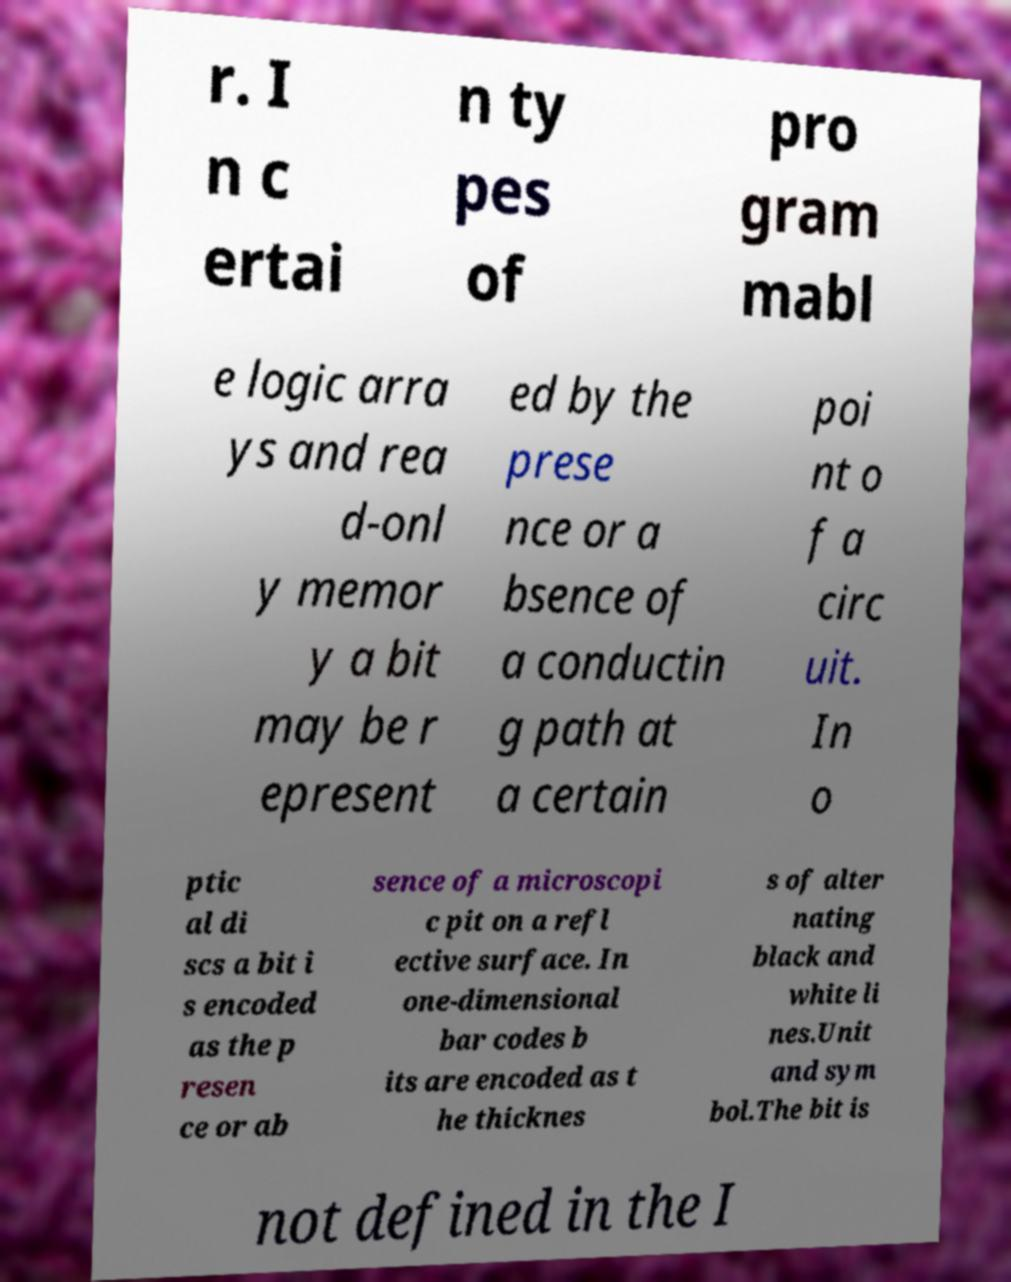Can you read and provide the text displayed in the image?This photo seems to have some interesting text. Can you extract and type it out for me? r. I n c ertai n ty pes of pro gram mabl e logic arra ys and rea d-onl y memor y a bit may be r epresent ed by the prese nce or a bsence of a conductin g path at a certain poi nt o f a circ uit. In o ptic al di scs a bit i s encoded as the p resen ce or ab sence of a microscopi c pit on a refl ective surface. In one-dimensional bar codes b its are encoded as t he thicknes s of alter nating black and white li nes.Unit and sym bol.The bit is not defined in the I 